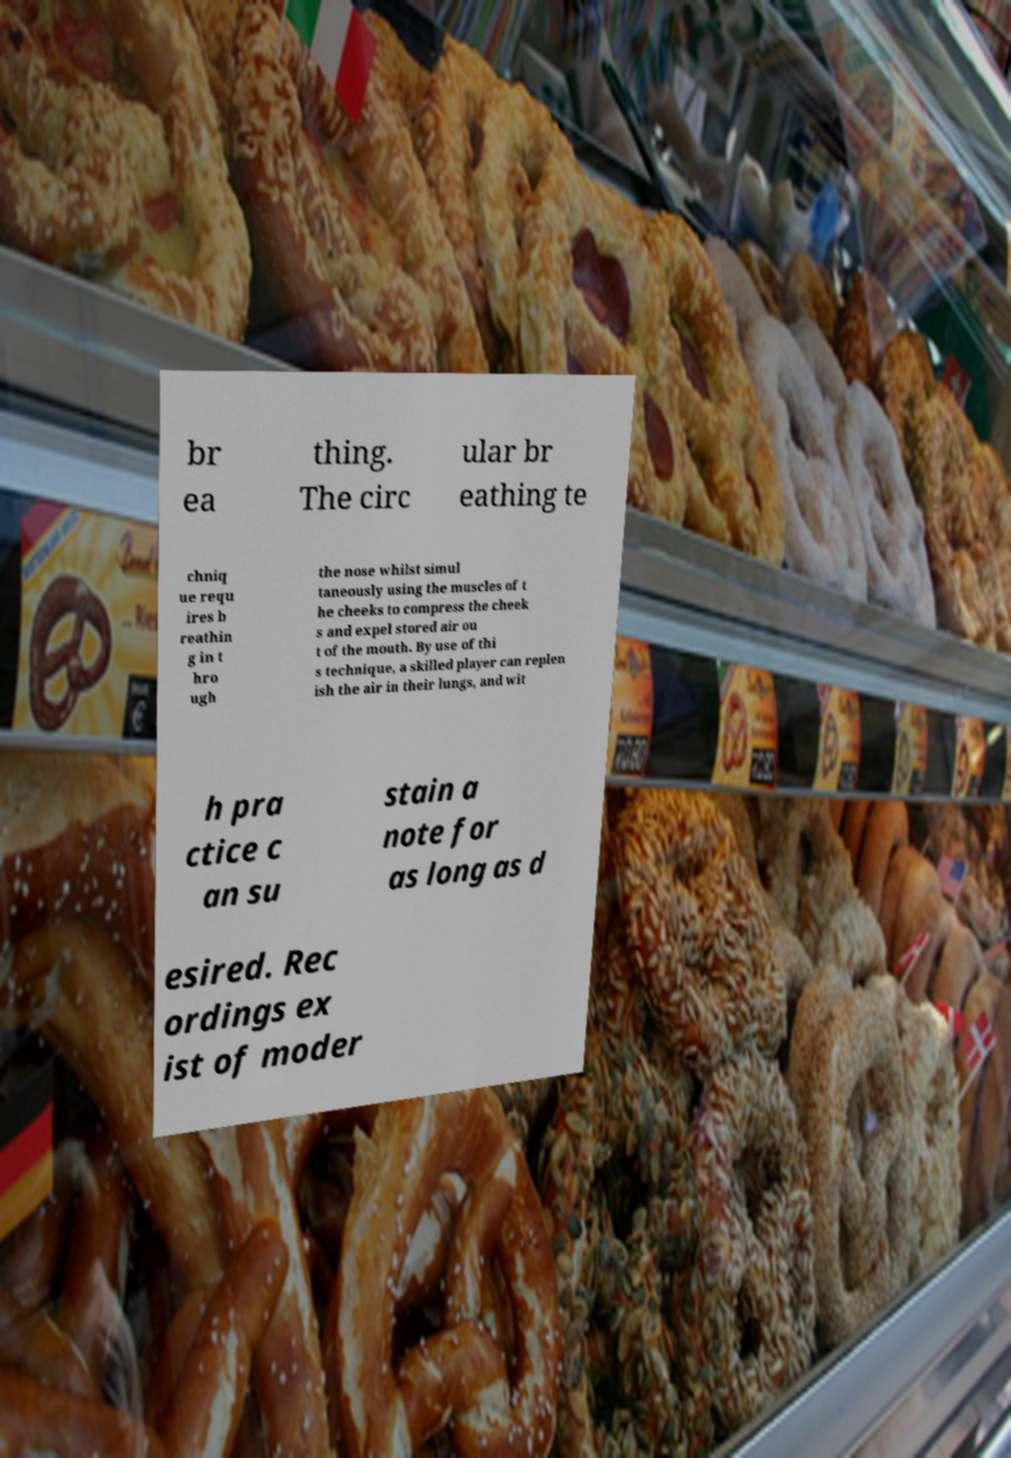I need the written content from this picture converted into text. Can you do that? br ea thing. The circ ular br eathing te chniq ue requ ires b reathin g in t hro ugh the nose whilst simul taneously using the muscles of t he cheeks to compress the cheek s and expel stored air ou t of the mouth. By use of thi s technique, a skilled player can replen ish the air in their lungs, and wit h pra ctice c an su stain a note for as long as d esired. Rec ordings ex ist of moder 